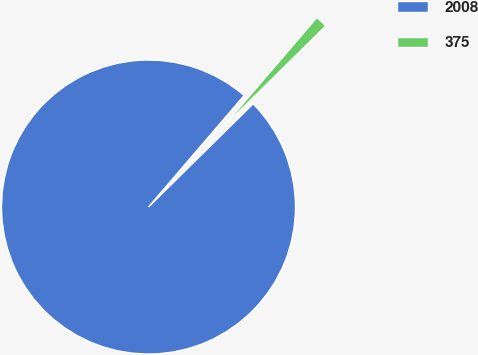<chart> <loc_0><loc_0><loc_500><loc_500><pie_chart><fcel>2008<fcel>375<nl><fcel>98.67%<fcel>1.33%<nl></chart> 